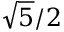Convert formula to latex. <formula><loc_0><loc_0><loc_500><loc_500>{ \sqrt { 5 } } / 2</formula> 